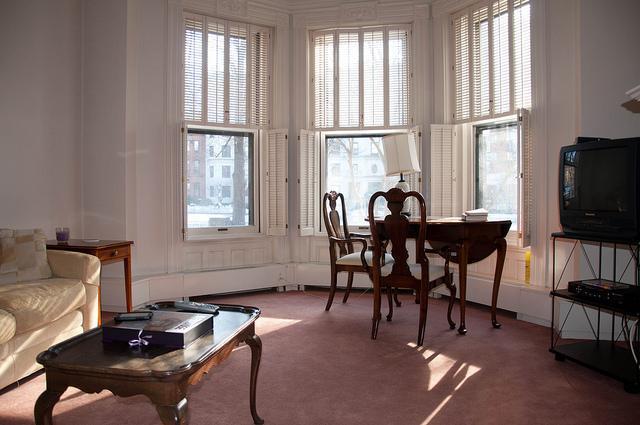How many chairs are there?
Give a very brief answer. 2. 